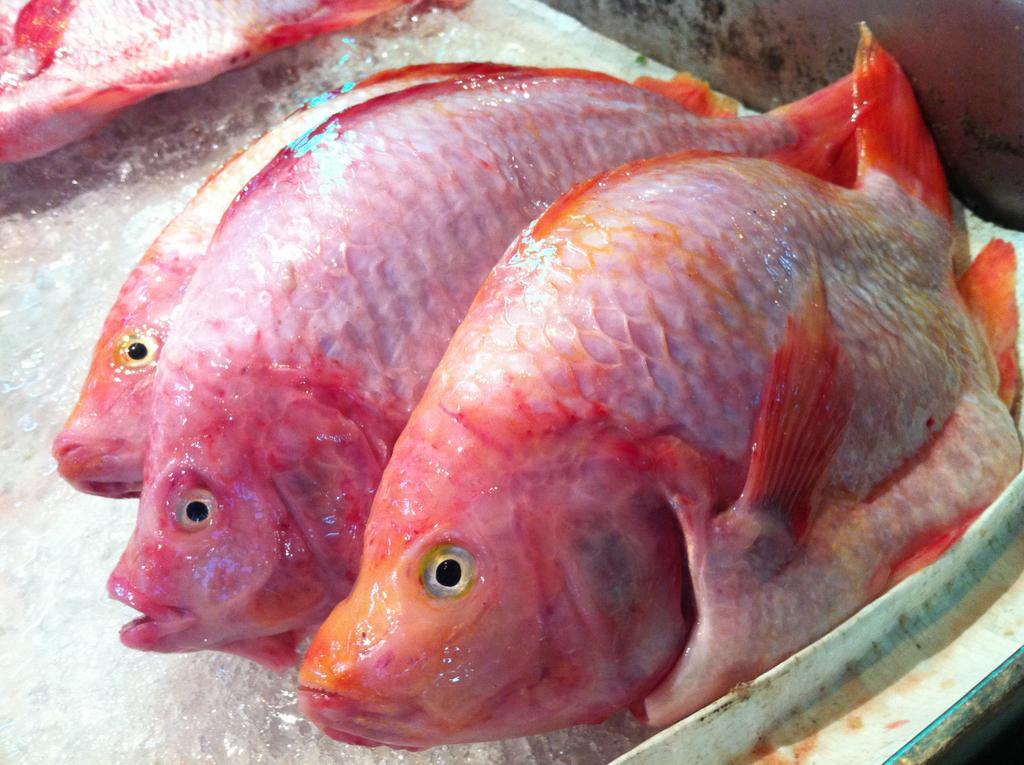How would you summarize this image in a sentence or two? In this image we can see fishes are kept in a white color container. 